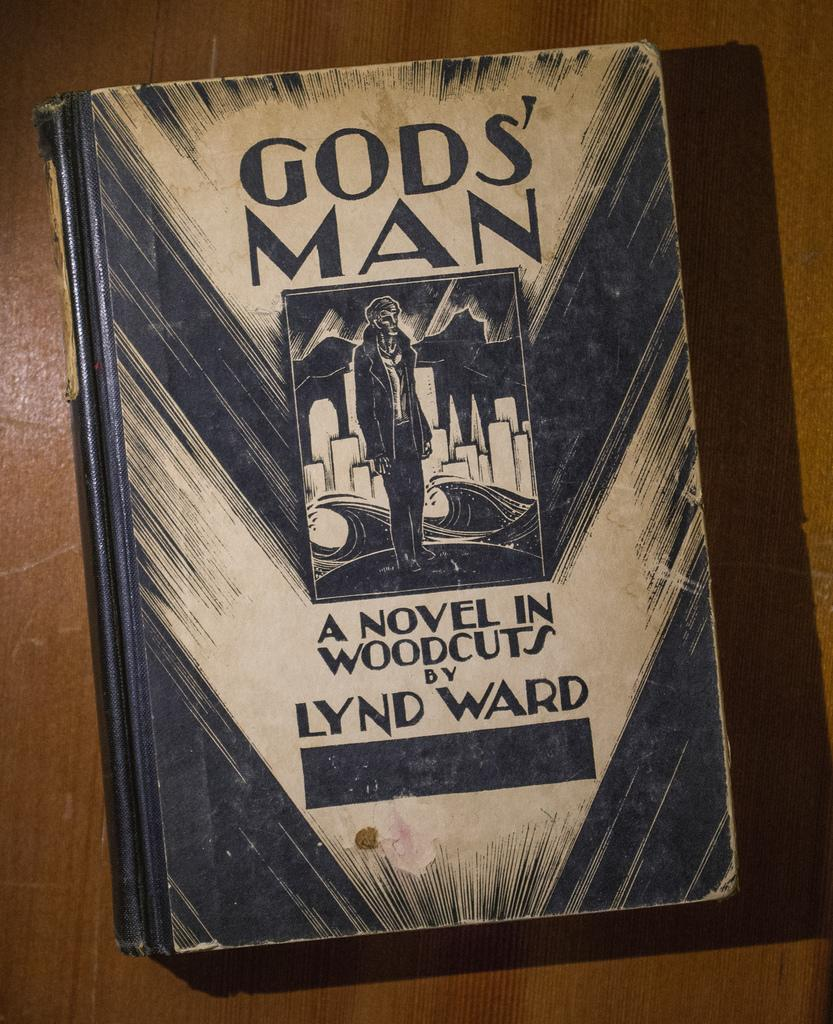Provide a one-sentence caption for the provided image. A book by the title of Gos' Man. 